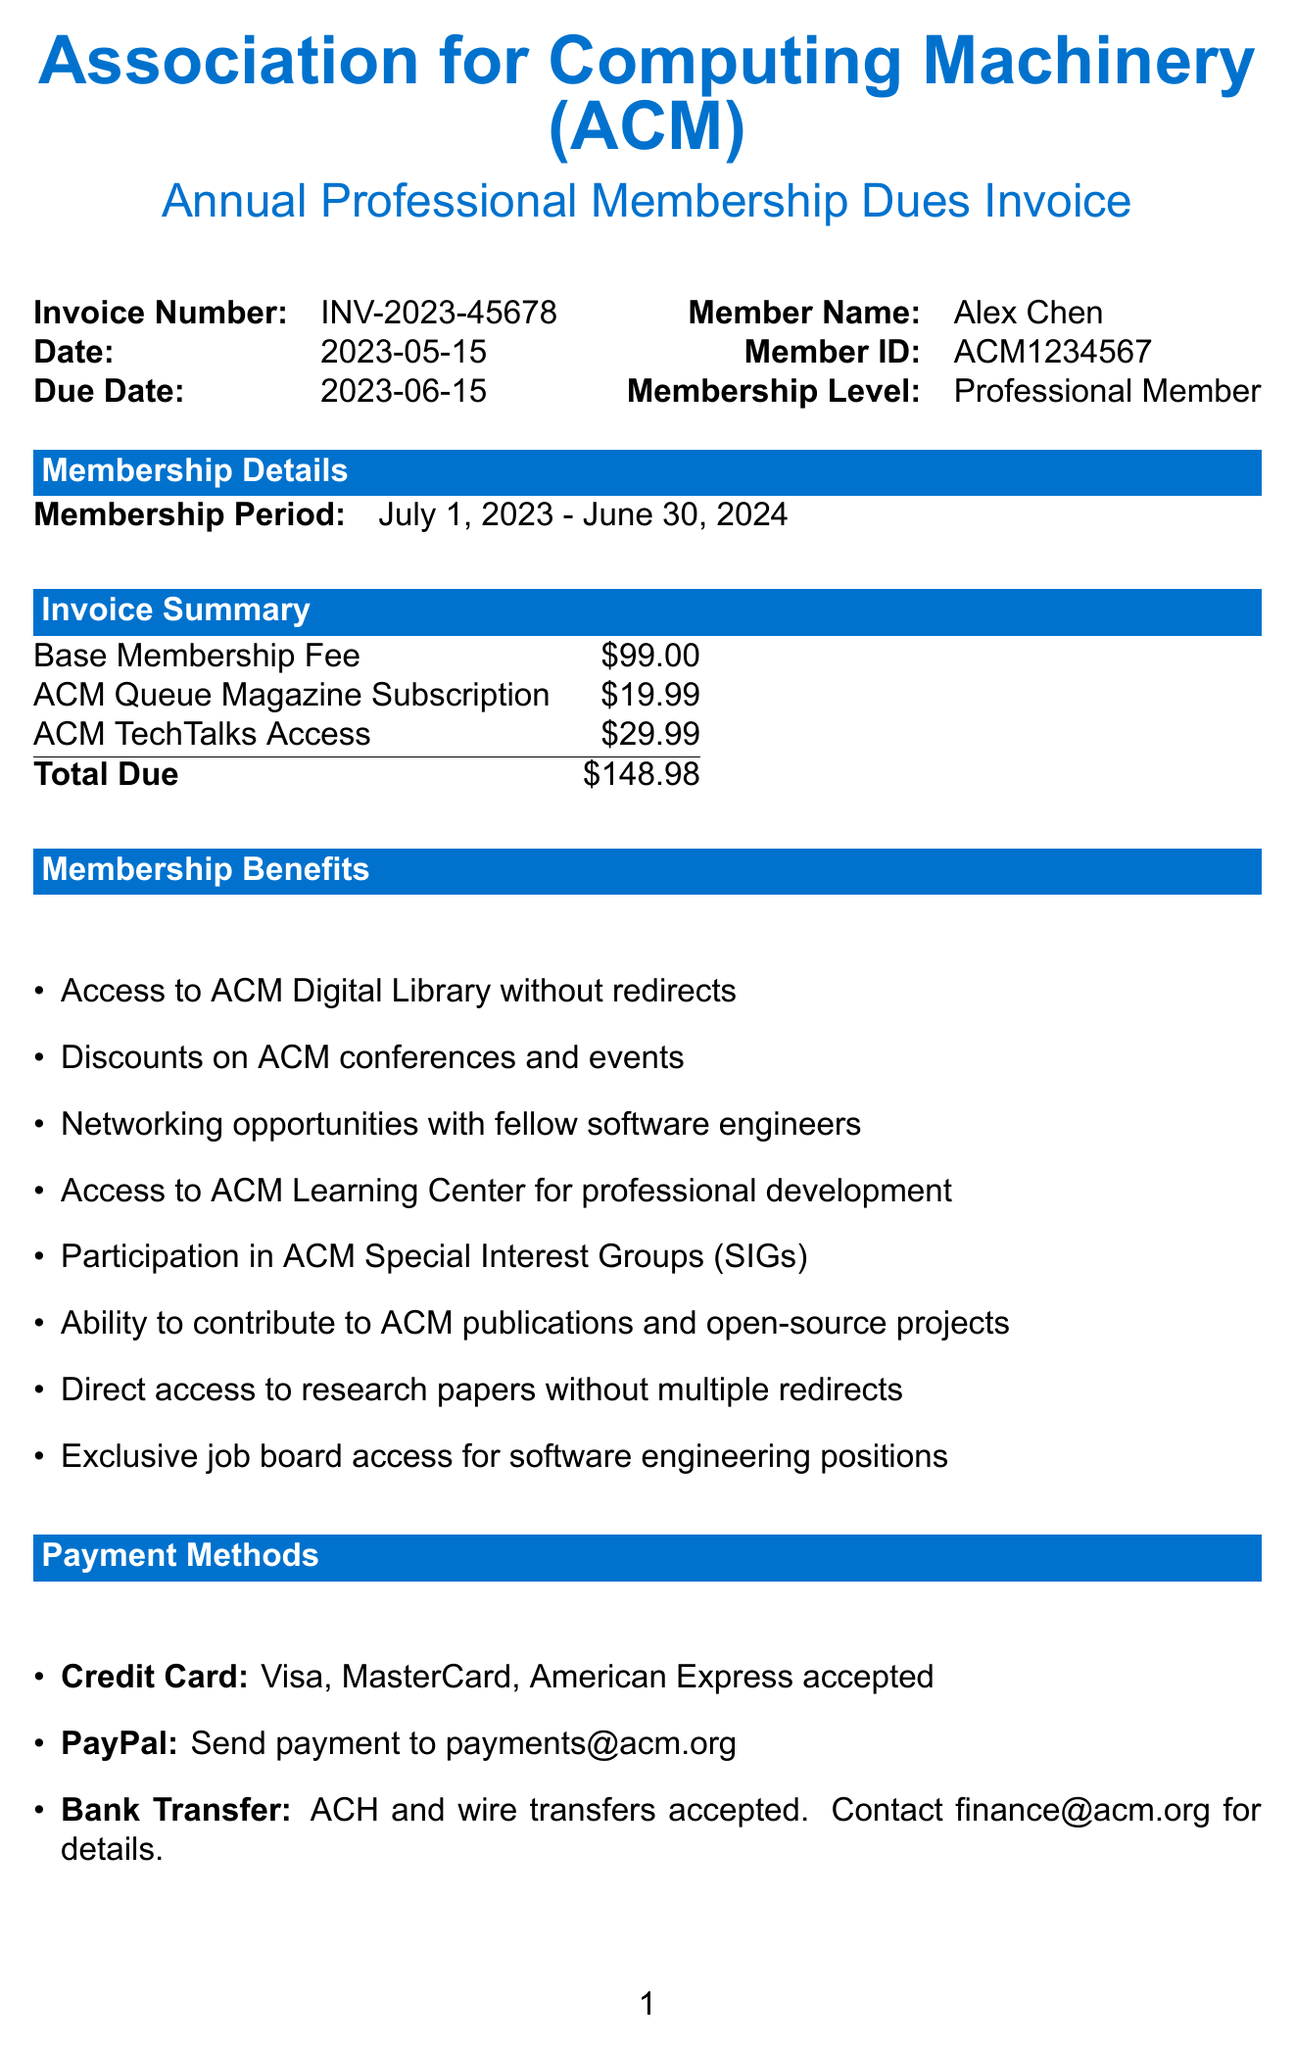What is the name of the organization? The organization name is listed at the top of the document.
Answer: Association for Computing Machinery (ACM) What is the invoice number? The invoice number is displayed under the header section of the document.
Answer: INV-2023-45678 What is the due date for the invoice? The due date is specified in the invoice details section.
Answer: 2023-06-15 How much is the base membership fee? The base membership fee is mentioned in the invoice summary section.
Answer: $99.00 What is the membership period? The membership period is outlined in the membership details section.
Answer: July 1, 2023 - June 30, 2024 Name one benefit of membership. Membership benefits are listed under the membership benefits section of the document.
Answer: Access to ACM Digital Library without redirects What payment methods are accepted? Payment methods are described in the payment methods section.
Answer: Credit Card, PayPal, Bank Transfer What is the total amount due? The total due is calculated in the invoice summary section.
Answer: $148.98 What is the contact email for assistance? The contact email is provided in the contact information section.
Answer: acmhelp@acm.org 